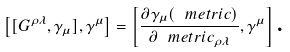Convert formula to latex. <formula><loc_0><loc_0><loc_500><loc_500>\left [ [ G ^ { \rho \lambda } , \gamma _ { \mu } ] , \gamma ^ { \mu } \right ] = \left [ \frac { \partial \gamma _ { \mu } ( \ m e t r i c ) } { \partial \ m e t r i c _ { \rho \lambda } } , \gamma ^ { \mu } \right ] \text {.}</formula> 